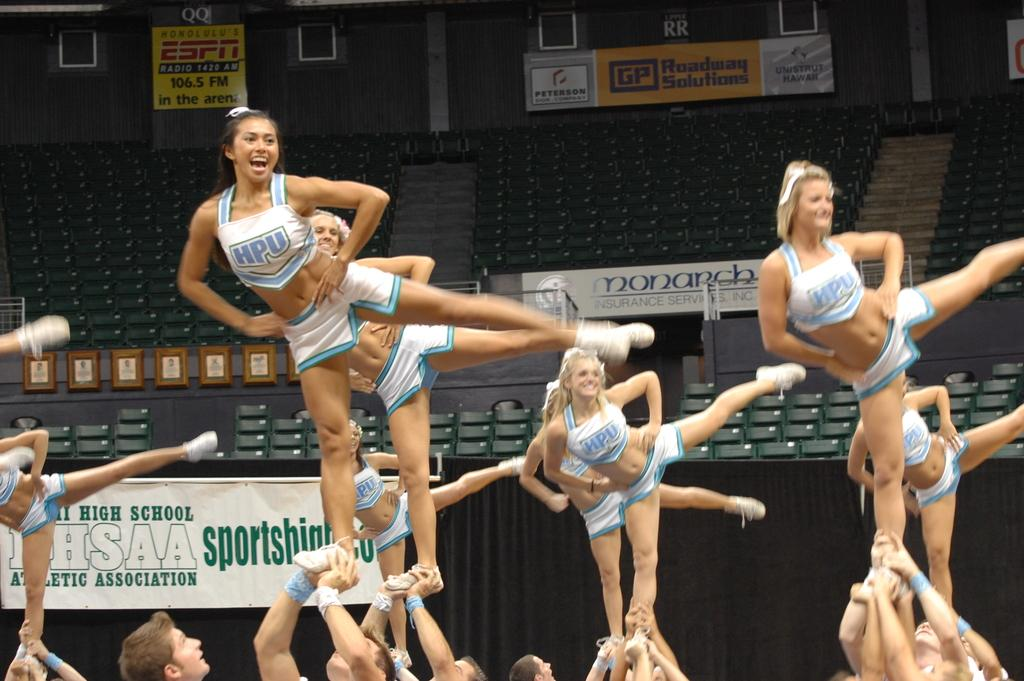<image>
Share a concise interpretation of the image provided. the word sportsmanship is on a sign near the people 